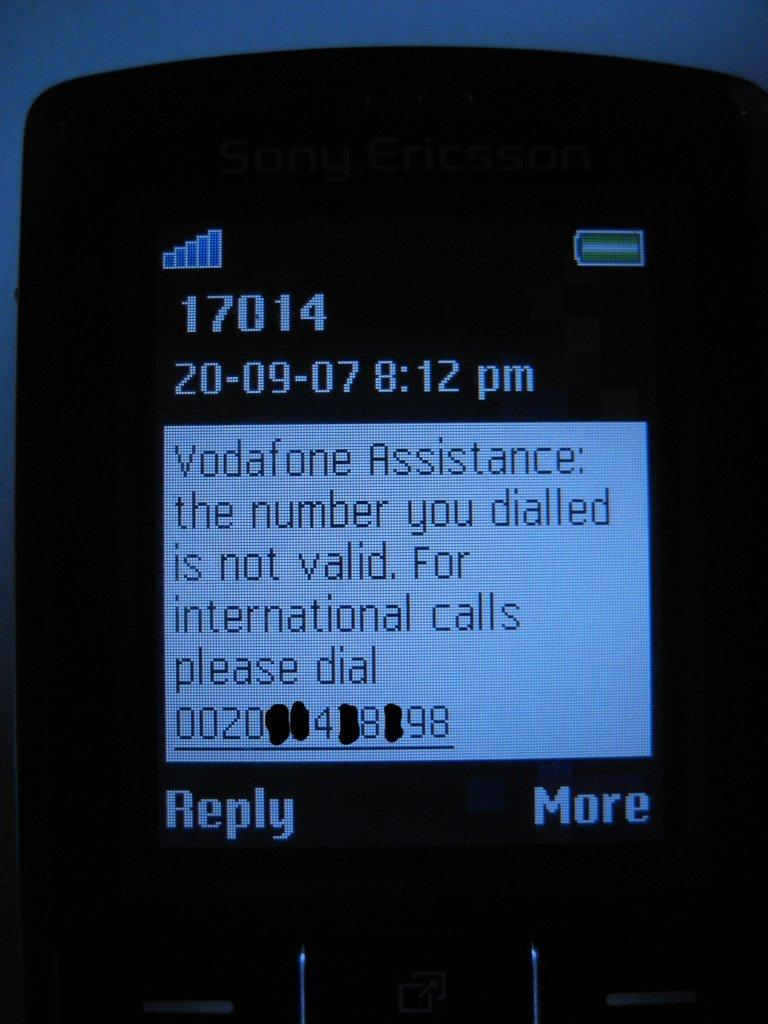What object is present in the image that can be moved or manipulated? There is a mobile in the image that can be moved or manipulated. What can be seen on the mobile? There is text visible on the mobile. What type of carpenter tools can be seen on the mobile in the image? There are no carpenter tools visible on the mobile in the image. How many dinosaurs are present on the mobile in the image? There are no dinosaurs present on the mobile in the image. 